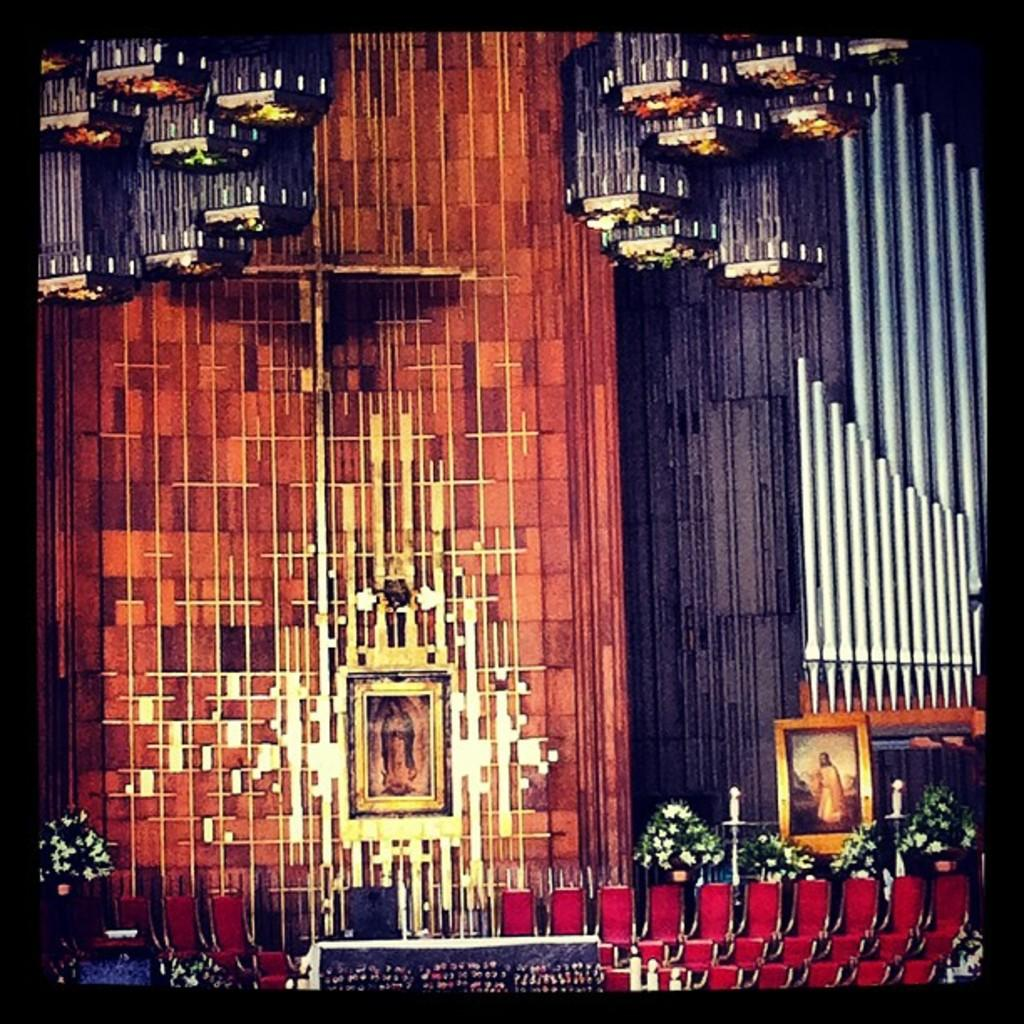What objects are located in the middle of the image? There are photo frames, candles, and flower vases in the middle of the image. What architectural feature can be seen in the image? There is a staircase in the image. What type of illumination is present in the image? There are lights in the image. What additional elements contribute to the decoration of the scene? There are decorations in the image. What is the background of the image composed of? There is a wall in the image. What type of corn is being used as a decoration in the image? There is no corn present in the image; it features photo frames, candles, flower vases, a staircase, lights, decorations, and a wall. Can you see a pig in the image? No, there is no pig present in the image. 